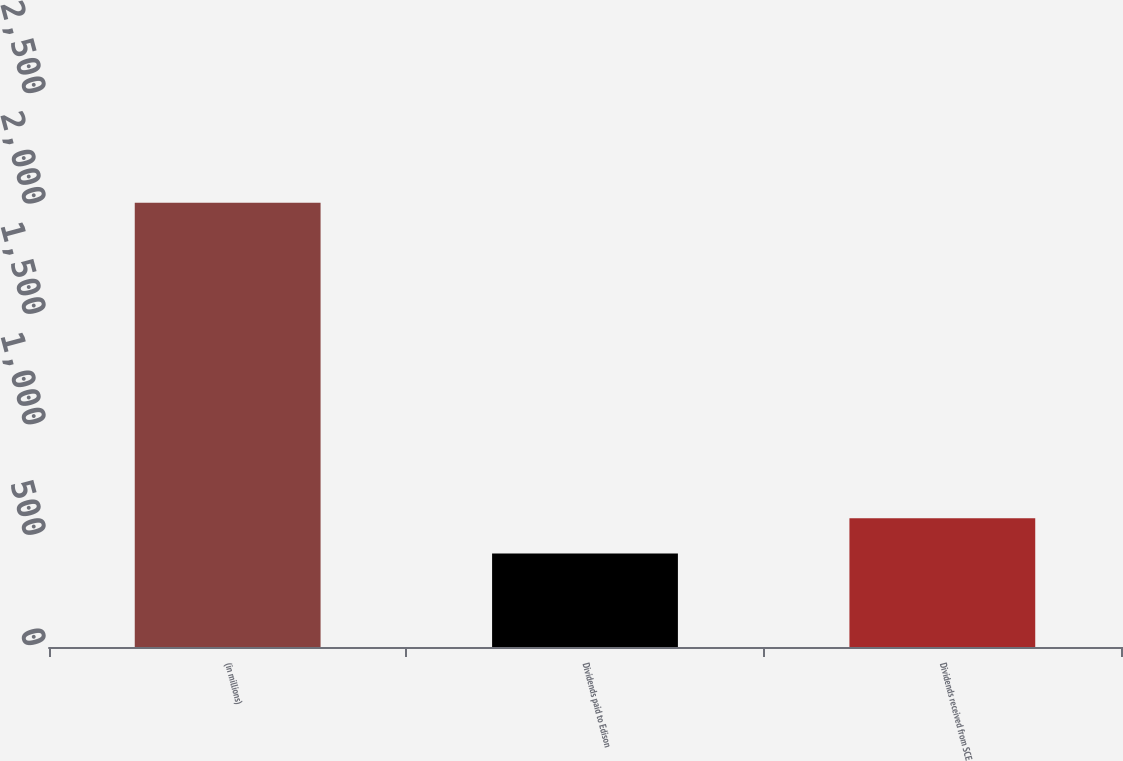Convert chart to OTSL. <chart><loc_0><loc_0><loc_500><loc_500><bar_chart><fcel>(in millions)<fcel>Dividends paid to Edison<fcel>Dividends received from SCE<nl><fcel>2012<fcel>424<fcel>582.8<nl></chart> 